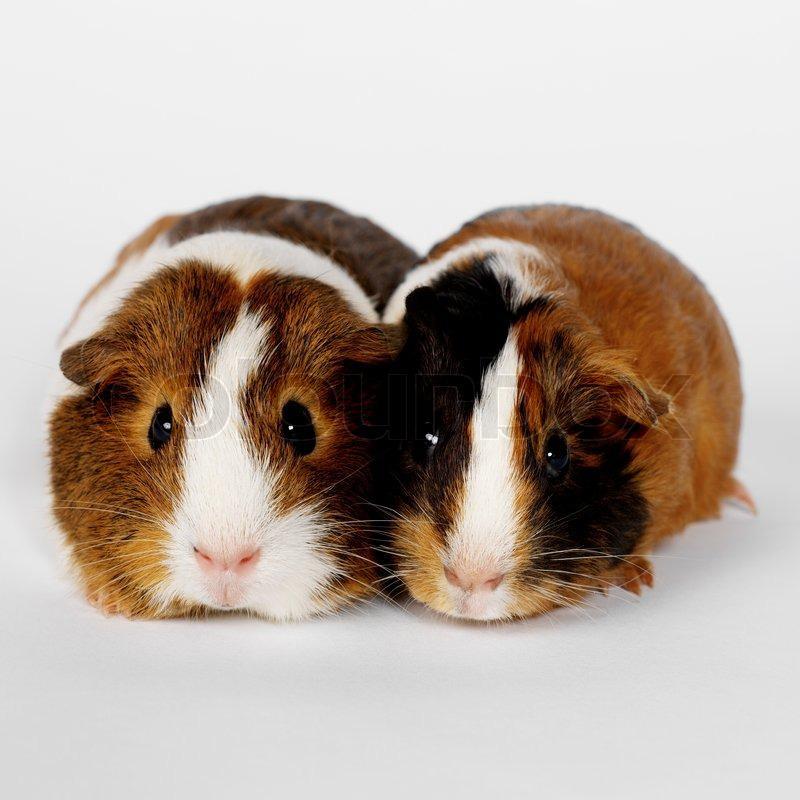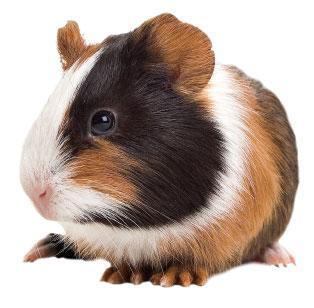The first image is the image on the left, the second image is the image on the right. Examine the images to the left and right. Is the description "There is at least one Guinea pig with an object in it's mouth." accurate? Answer yes or no. No. The first image is the image on the left, the second image is the image on the right. Considering the images on both sides, is "Each image contains exactly one guinea pig figure, and one image shows a guinea pig on a plush white textured fabric." valid? Answer yes or no. No. 